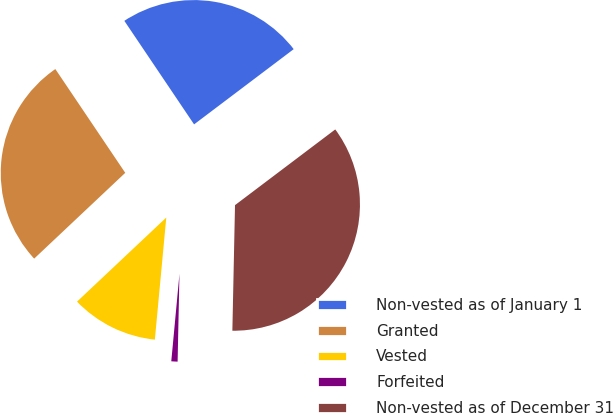Convert chart to OTSL. <chart><loc_0><loc_0><loc_500><loc_500><pie_chart><fcel>Non-vested as of January 1<fcel>Granted<fcel>Vested<fcel>Forfeited<fcel>Non-vested as of December 31<nl><fcel>24.14%<fcel>27.59%<fcel>11.49%<fcel>1.15%<fcel>35.63%<nl></chart> 